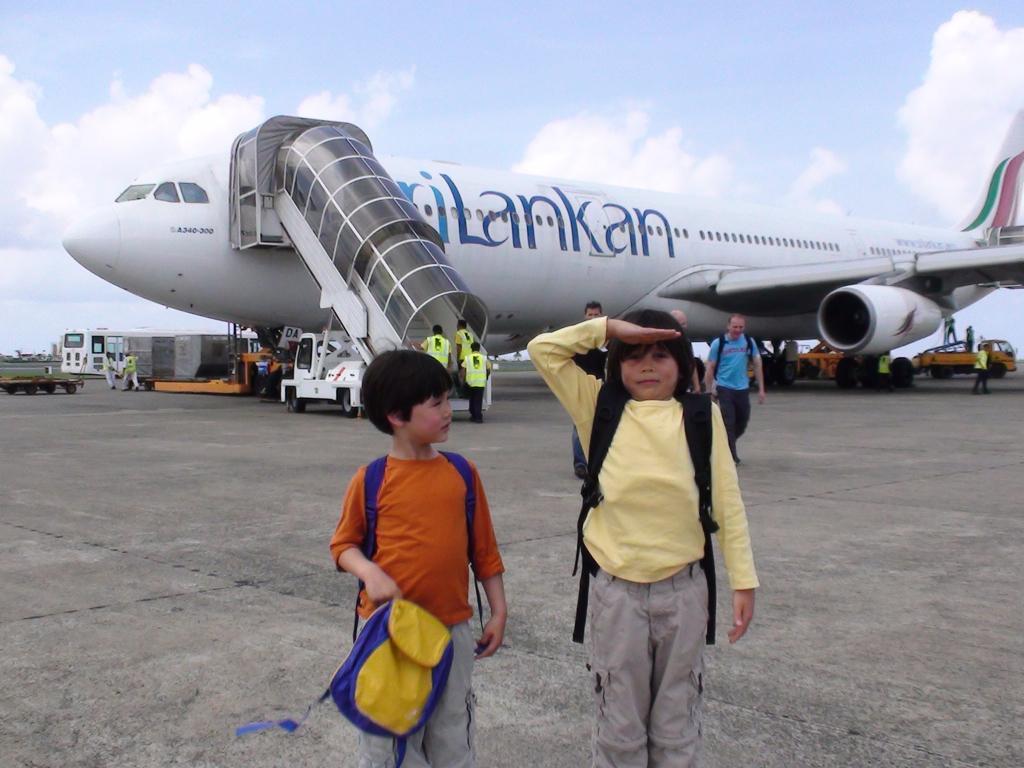Describe this image in one or two sentences. In this image, I can see few people standing and few people walking. There are vehicles and an airplane with passenger steps on the runway. In the background, there is the sky. 